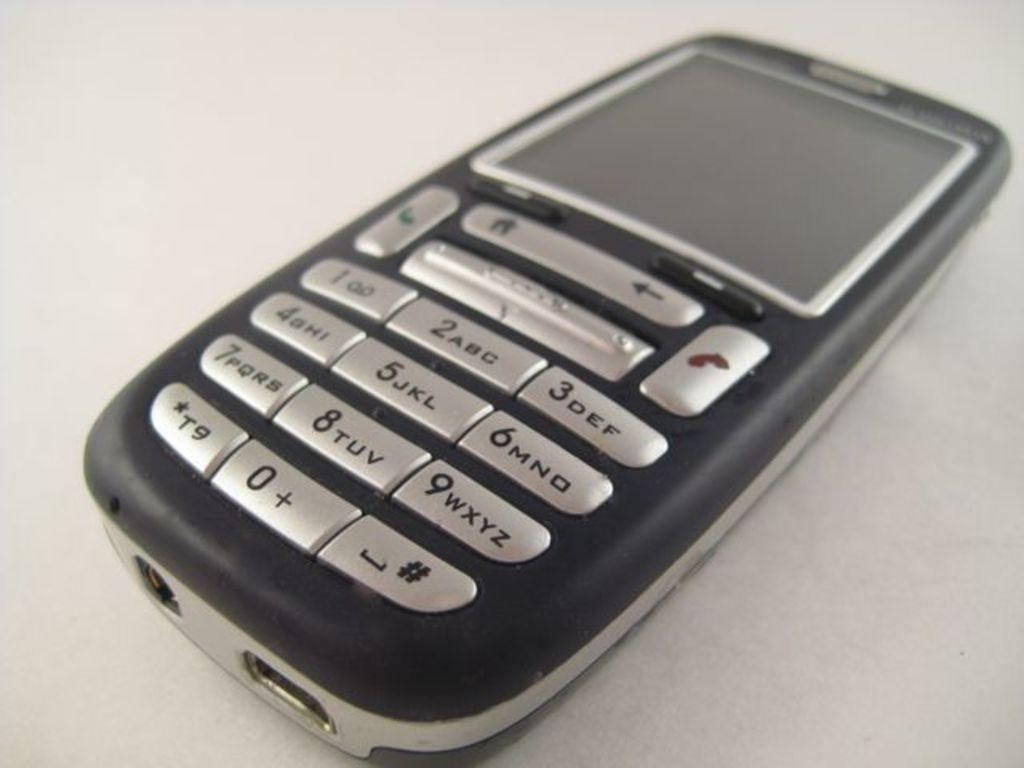<image>
Present a compact description of the photo's key features. A phone features a button that includes the number 9 and the letters W through Z on it. 